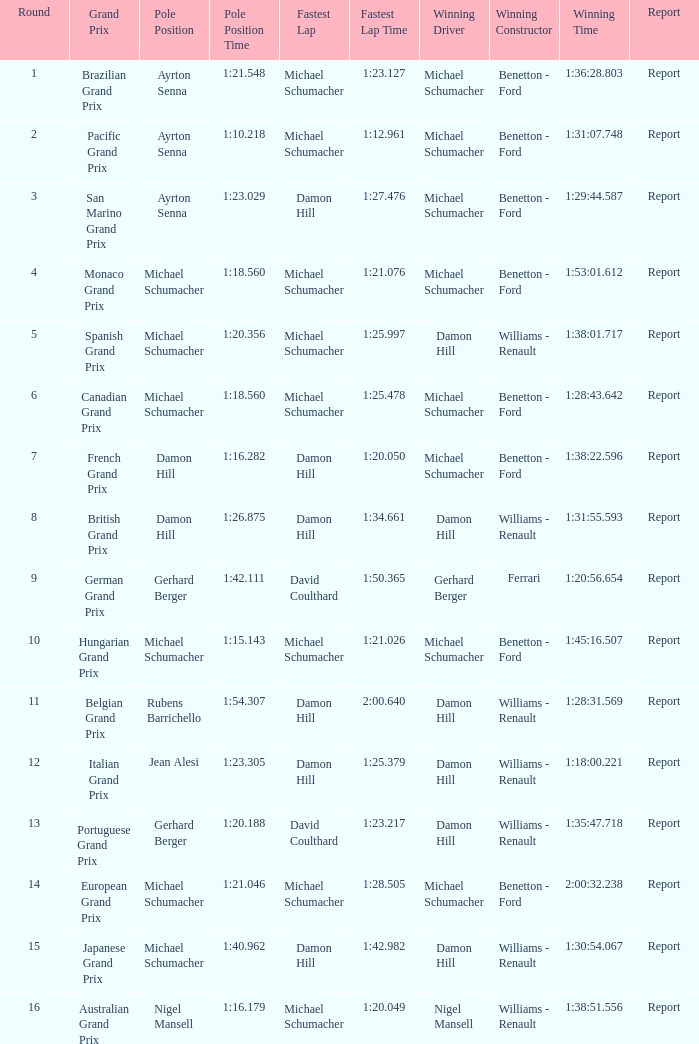Name the fastest lap for the brazilian grand prix Michael Schumacher. Could you parse the entire table as a dict? {'header': ['Round', 'Grand Prix', 'Pole Position', 'Pole Position Time', 'Fastest Lap', 'Fastest Lap Time', 'Winning Driver', 'Winning Constructor', 'Winning Time', 'Report'], 'rows': [['1', 'Brazilian Grand Prix', 'Ayrton Senna', '1:21.548', 'Michael Schumacher', '1:23.127', 'Michael Schumacher', 'Benetton - Ford', '1:36:28.803', 'Report'], ['2', 'Pacific Grand Prix', 'Ayrton Senna', '1:10.218', 'Michael Schumacher', '1:12.961', 'Michael Schumacher', 'Benetton - Ford', '1:31:07.748', 'Report'], ['3', 'San Marino Grand Prix', 'Ayrton Senna', '1:23.029', 'Damon Hill', '1:27.476', 'Michael Schumacher', 'Benetton - Ford', '1:29:44.587', 'Report'], ['4', 'Monaco Grand Prix', 'Michael Schumacher', '1:18.560', 'Michael Schumacher', '1:21.076', 'Michael Schumacher', 'Benetton - Ford', '1:53:01.612', 'Report'], ['5', 'Spanish Grand Prix', 'Michael Schumacher', '1:20.356', 'Michael Schumacher', '1:25.997', 'Damon Hill', 'Williams - Renault', '1:38:01.717', 'Report'], ['6', 'Canadian Grand Prix', 'Michael Schumacher', '1:18.560', 'Michael Schumacher', '1:25.478', 'Michael Schumacher', 'Benetton - Ford', '1:28:43.642', 'Report'], ['7', 'French Grand Prix', 'Damon Hill', '1:16.282', 'Damon Hill', '1:20.050', 'Michael Schumacher', 'Benetton - Ford', '1:38:22.596', 'Report'], ['8', 'British Grand Prix', 'Damon Hill', '1:26.875', 'Damon Hill', '1:34.661', 'Damon Hill', 'Williams - Renault', '1:31:55.593', 'Report'], ['9', 'German Grand Prix', 'Gerhard Berger', '1:42.111', 'David Coulthard', '1:50.365', 'Gerhard Berger', 'Ferrari', '1:20:56.654', 'Report'], ['10', 'Hungarian Grand Prix', 'Michael Schumacher', '1:15.143', 'Michael Schumacher', '1:21.026', 'Michael Schumacher', 'Benetton - Ford', '1:45:16.507', 'Report'], ['11', 'Belgian Grand Prix', 'Rubens Barrichello', '1:54.307', 'Damon Hill', '2:00.640', 'Damon Hill', 'Williams - Renault', '1:28:31.569', 'Report'], ['12', 'Italian Grand Prix', 'Jean Alesi', '1:23.305', 'Damon Hill', '1:25.379', 'Damon Hill', 'Williams - Renault', '1:18:00.221', 'Report'], ['13', 'Portuguese Grand Prix', 'Gerhard Berger', '1:20.188', 'David Coulthard', '1:23.217', 'Damon Hill', 'Williams - Renault', '1:35:47.718', 'Report'], ['14', 'European Grand Prix', 'Michael Schumacher', '1:21.046', 'Michael Schumacher', '1:28.505', 'Michael Schumacher', 'Benetton - Ford', '2:00:32.238', 'Report'], ['15', 'Japanese Grand Prix', 'Michael Schumacher', '1:40.962', 'Damon Hill', '1:42.982', 'Damon Hill', 'Williams - Renault', '1:30:54.067', 'Report'], ['16', 'Australian Grand Prix', 'Nigel Mansell', '1:16.179', 'Michael Schumacher', '1:20.049', 'Nigel Mansell', 'Williams - Renault', '1:38:51.556', 'Report']]} 